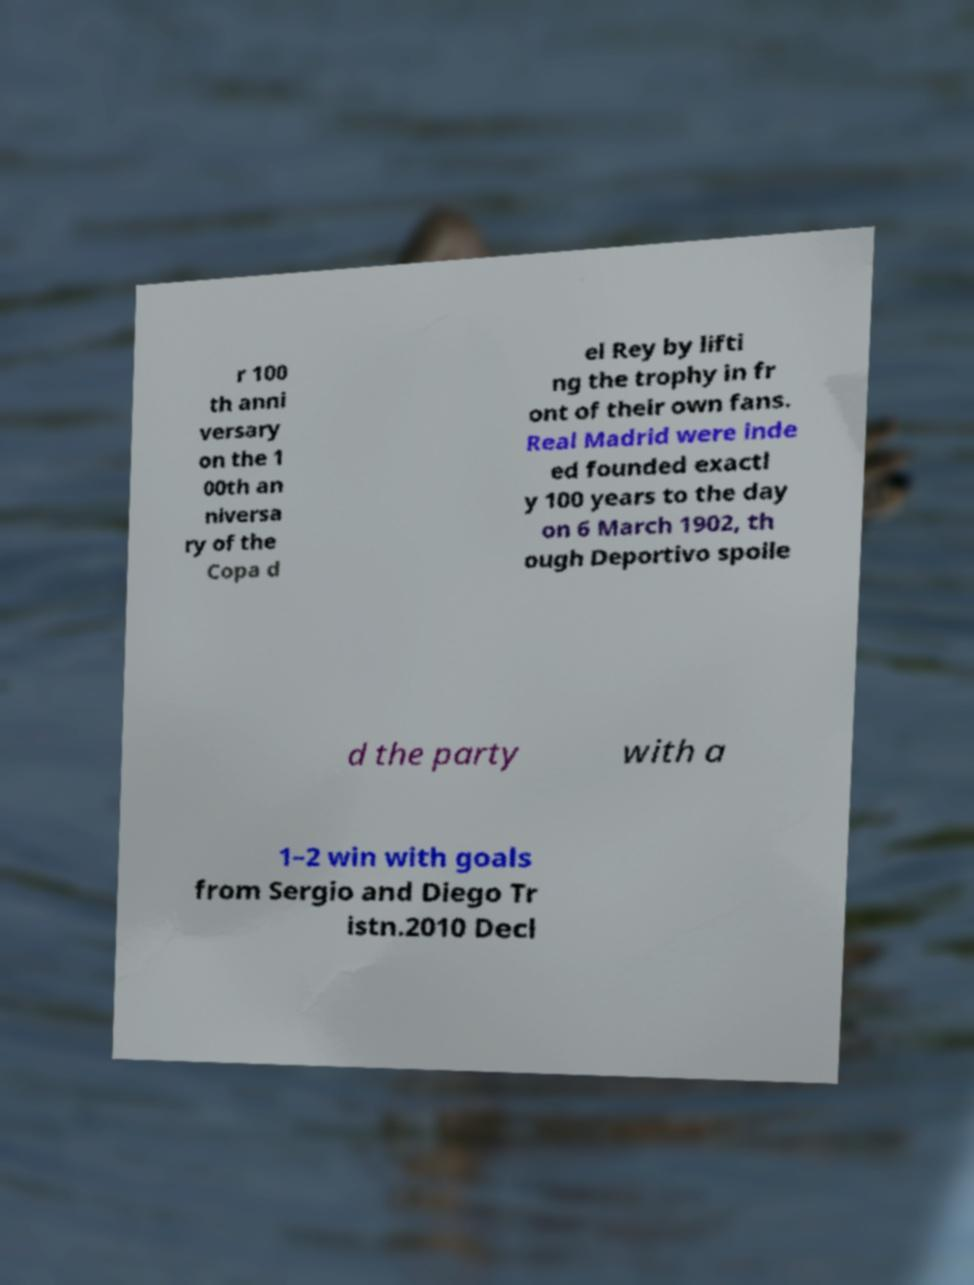Please read and relay the text visible in this image. What does it say? r 100 th anni versary on the 1 00th an niversa ry of the Copa d el Rey by lifti ng the trophy in fr ont of their own fans. Real Madrid were inde ed founded exactl y 100 years to the day on 6 March 1902, th ough Deportivo spoile d the party with a 1–2 win with goals from Sergio and Diego Tr istn.2010 Decl 